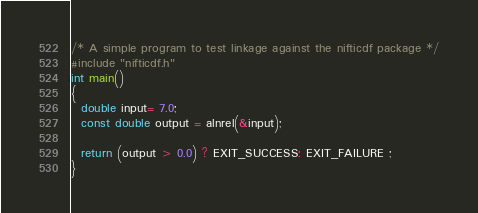<code> <loc_0><loc_0><loc_500><loc_500><_C_>/* A simple program to test linkage against the nifticdf package */
#include "nifticdf.h"
int main()
{
  double input= 7.0;
  const double output = alnrel(&input);

  return (output > 0.0) ? EXIT_SUCCESS: EXIT_FAILURE ;
}
</code> 